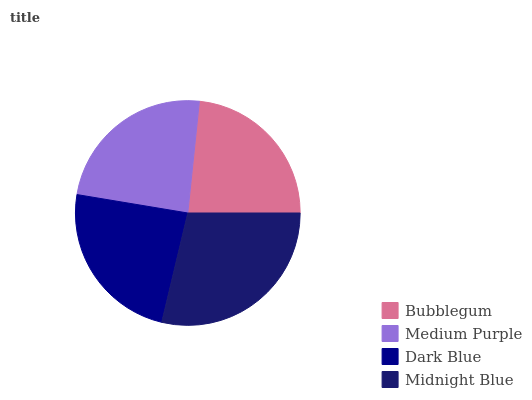Is Bubblegum the minimum?
Answer yes or no. Yes. Is Midnight Blue the maximum?
Answer yes or no. Yes. Is Medium Purple the minimum?
Answer yes or no. No. Is Medium Purple the maximum?
Answer yes or no. No. Is Medium Purple greater than Bubblegum?
Answer yes or no. Yes. Is Bubblegum less than Medium Purple?
Answer yes or no. Yes. Is Bubblegum greater than Medium Purple?
Answer yes or no. No. Is Medium Purple less than Bubblegum?
Answer yes or no. No. Is Medium Purple the high median?
Answer yes or no. Yes. Is Dark Blue the low median?
Answer yes or no. Yes. Is Bubblegum the high median?
Answer yes or no. No. Is Medium Purple the low median?
Answer yes or no. No. 